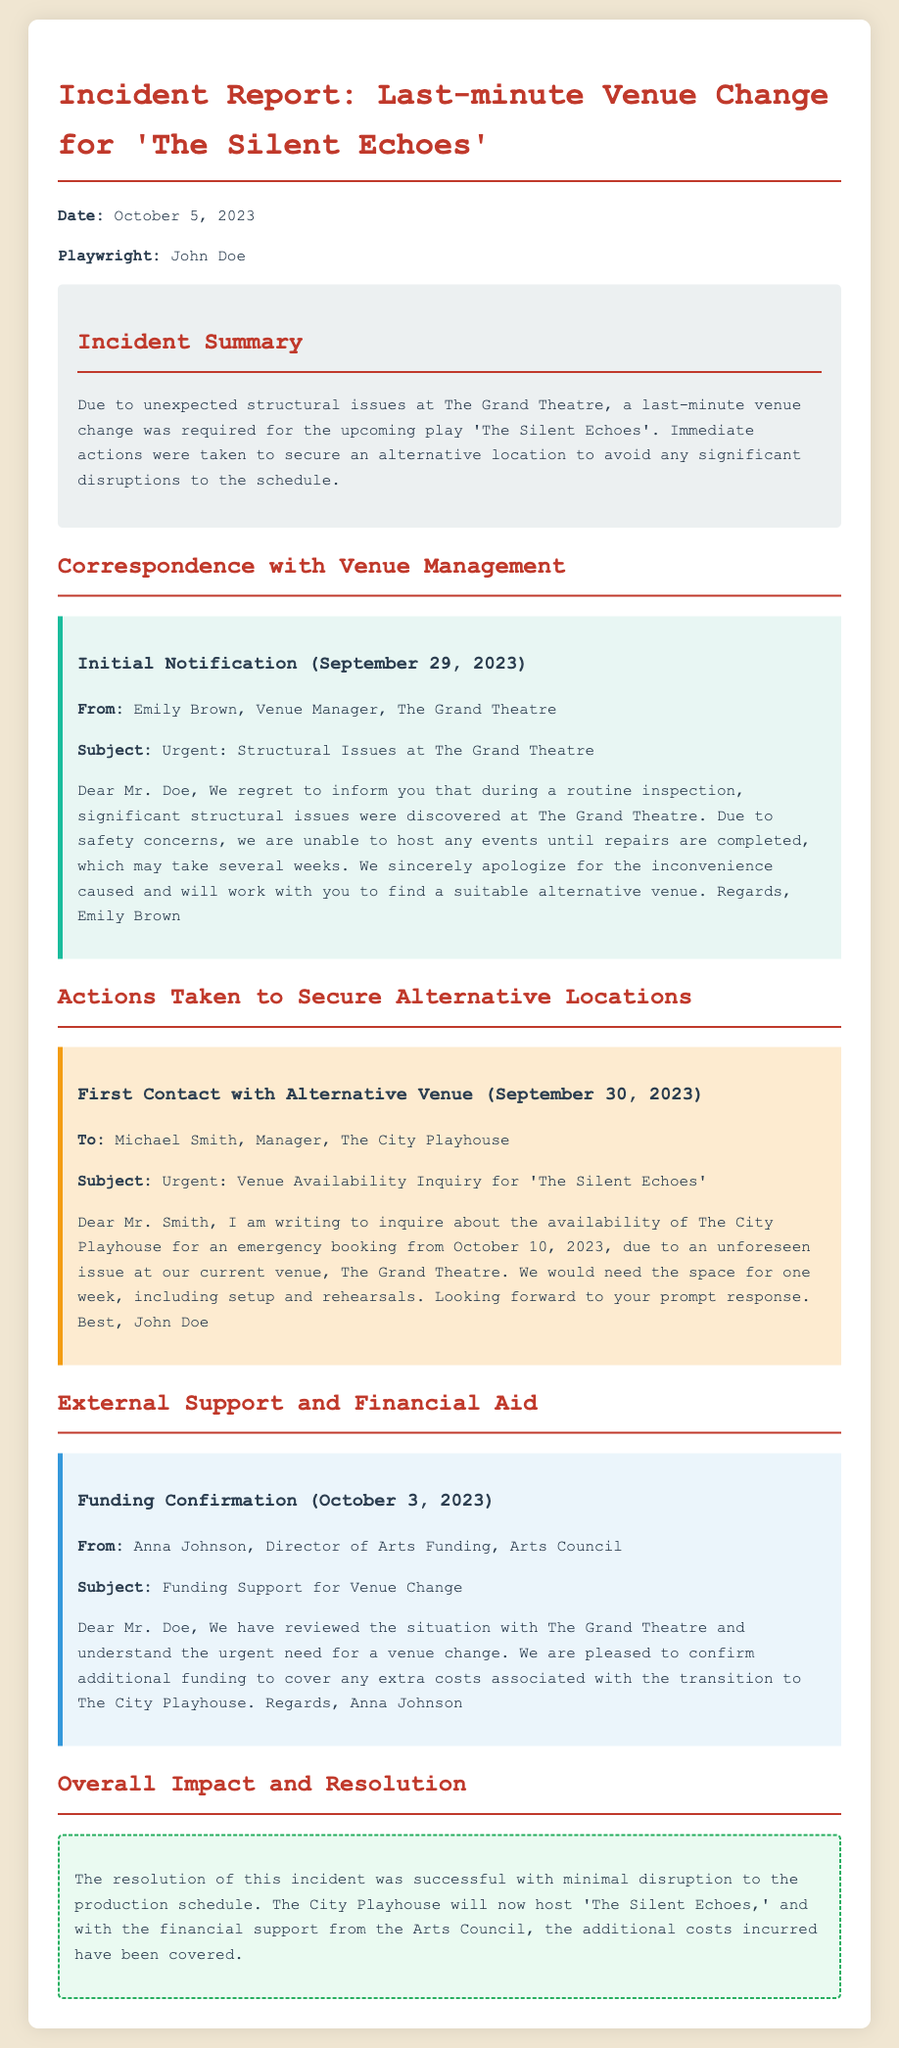What is the title of the play affected by the venue change? The title of the play is mentioned in the incident summary as 'The Silent Echoes'.
Answer: 'The Silent Echoes' Who is the playwright? The report specifies the playwright's name is John Doe.
Answer: John Doe When did the initial notification of structural issues occur? The initial notification date is stated as September 29, 2023, in the correspondence section.
Answer: September 29, 2023 Which venue is now hosting the play? The alternative venue that will now host the production is mentioned in the resolution as The City Playhouse.
Answer: The City Playhouse What confirmation was received from the Arts Council? The Arts Council confirmed additional funding for the venue change, as indicated in their correspondence.
Answer: Additional funding On what date was funding confirmation received? The funding confirmation date is specified as October 3, 2023, in the external support section.
Answer: October 3, 2023 What were the structural issues discovered? The nature of the issues is described as "significant structural issues" in the initial notification.
Answer: Significant structural issues How long may repairs at The Grand Theatre take? The document mentions that repairs may take "several weeks" based on the initial notification.
Answer: Several weeks What was the date of the first contact with the alternative venue? The first contact date with the alternative venue is indicated as September 30, 2023.
Answer: September 30, 2023 